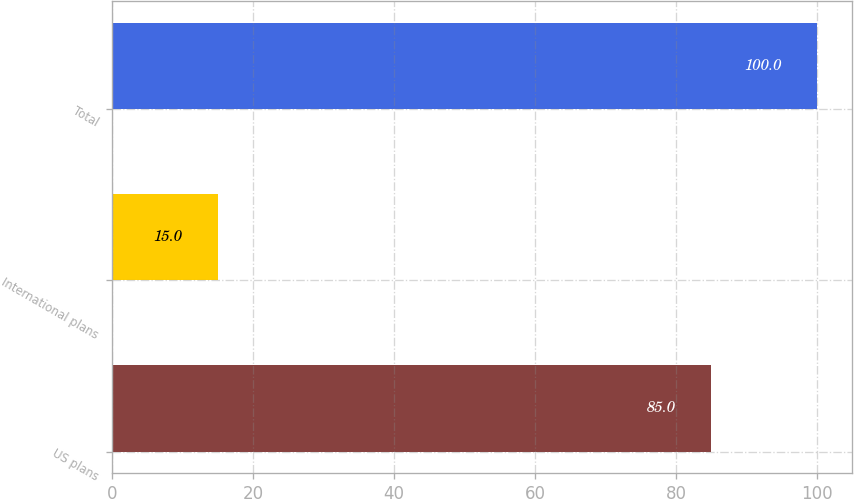<chart> <loc_0><loc_0><loc_500><loc_500><bar_chart><fcel>US plans<fcel>International plans<fcel>Total<nl><fcel>85<fcel>15<fcel>100<nl></chart> 